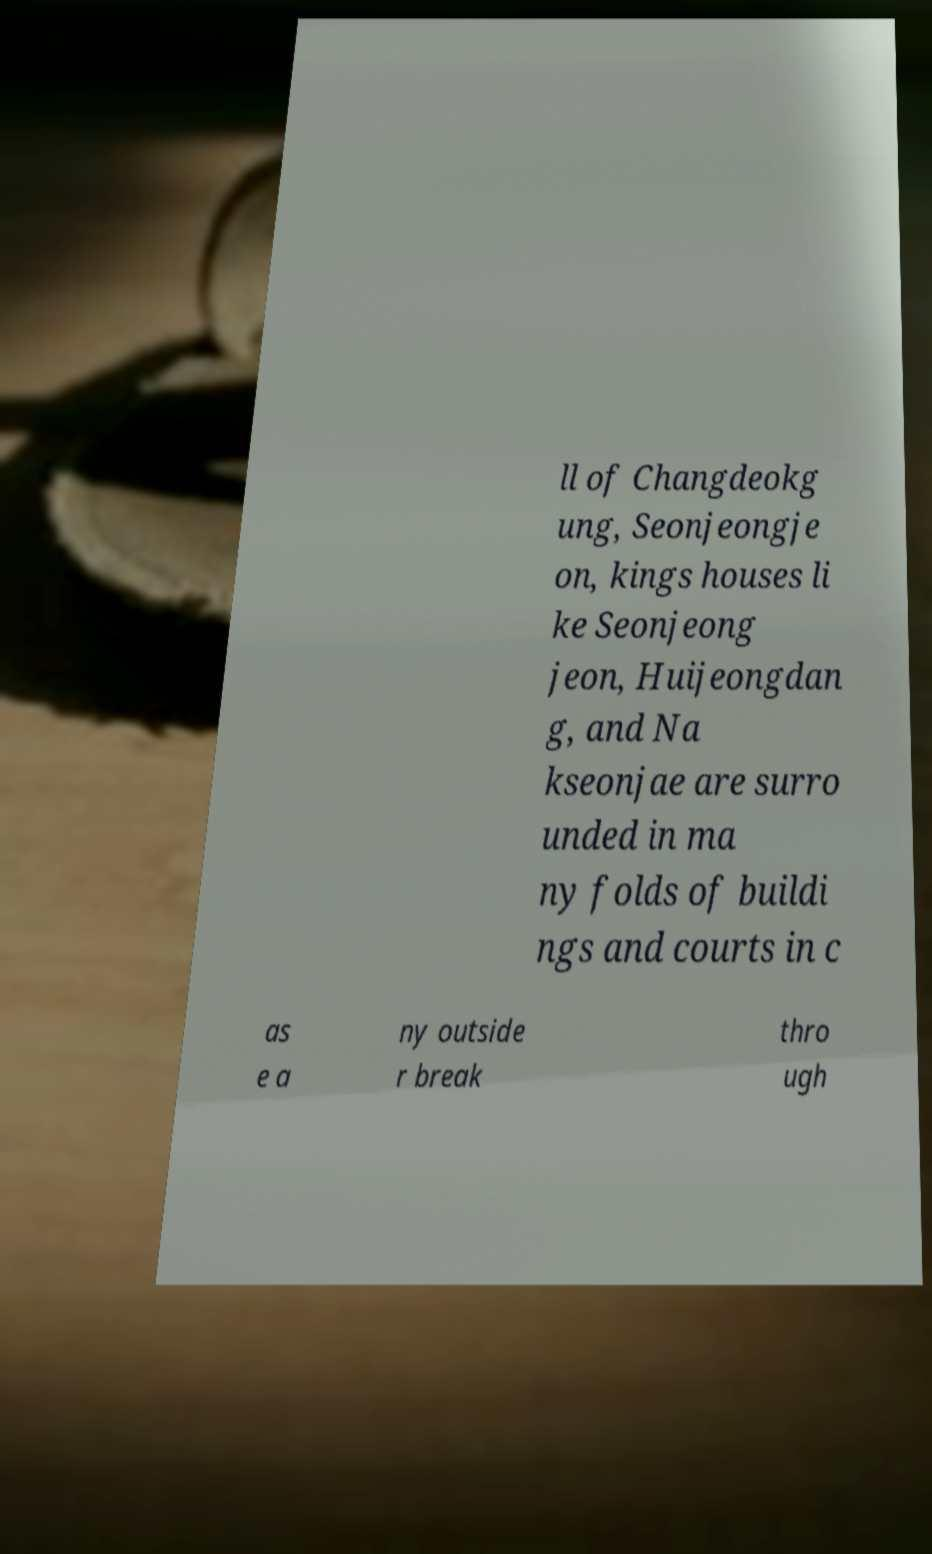Could you assist in decoding the text presented in this image and type it out clearly? ll of Changdeokg ung, Seonjeongje on, kings houses li ke Seonjeong jeon, Huijeongdan g, and Na kseonjae are surro unded in ma ny folds of buildi ngs and courts in c as e a ny outside r break thro ugh 